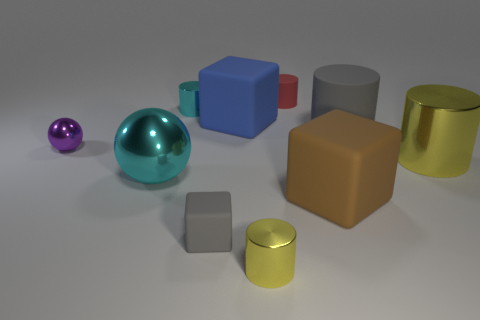What number of other objects are there of the same shape as the tiny red thing?
Your response must be concise. 4. The shiny object that is in front of the small gray matte thing has what shape?
Provide a short and direct response. Cylinder. Are there any small yellow things that have the same material as the small red cylinder?
Make the answer very short. No. There is a metallic object on the right side of the brown rubber object; is it the same color as the big ball?
Give a very brief answer. No. What is the size of the cyan sphere?
Ensure brevity in your answer.  Large. There is a thing left of the cyan thing that is in front of the tiny cyan thing; are there any large cylinders to the left of it?
Ensure brevity in your answer.  No. What number of big gray rubber cylinders are behind the small matte cylinder?
Provide a short and direct response. 0. How many big metallic things are the same color as the big matte cylinder?
Offer a very short reply. 0. How many objects are big things that are on the right side of the tiny gray block or small cylinders behind the gray matte cube?
Your answer should be very brief. 6. Are there more yellow cylinders than blue things?
Your response must be concise. Yes. 